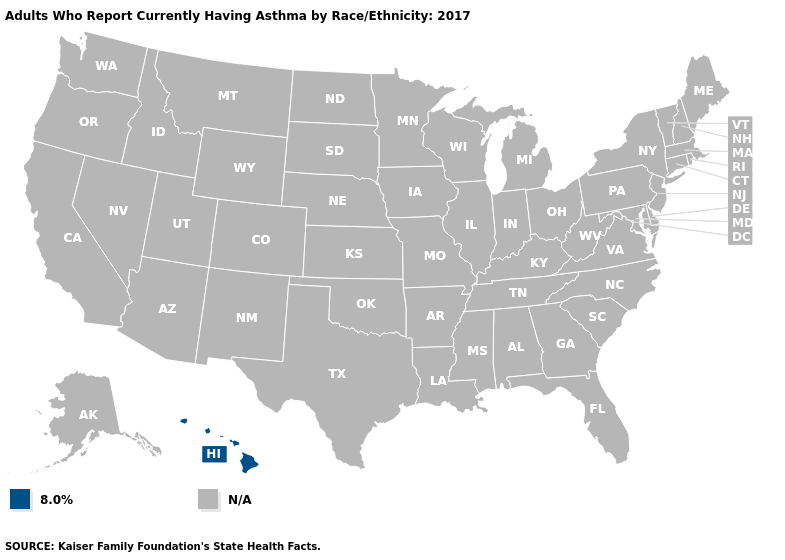How many symbols are there in the legend?
Answer briefly. 2. What is the value of Arkansas?
Write a very short answer. N/A. What is the value of Oregon?
Quick response, please. N/A. How many symbols are there in the legend?
Give a very brief answer. 2. How many symbols are there in the legend?
Short answer required. 2. Name the states that have a value in the range N/A?
Short answer required. Alabama, Alaska, Arizona, Arkansas, California, Colorado, Connecticut, Delaware, Florida, Georgia, Idaho, Illinois, Indiana, Iowa, Kansas, Kentucky, Louisiana, Maine, Maryland, Massachusetts, Michigan, Minnesota, Mississippi, Missouri, Montana, Nebraska, Nevada, New Hampshire, New Jersey, New Mexico, New York, North Carolina, North Dakota, Ohio, Oklahoma, Oregon, Pennsylvania, Rhode Island, South Carolina, South Dakota, Tennessee, Texas, Utah, Vermont, Virginia, Washington, West Virginia, Wisconsin, Wyoming. Name the states that have a value in the range 8.0%?
Be succinct. Hawaii. Name the states that have a value in the range N/A?
Write a very short answer. Alabama, Alaska, Arizona, Arkansas, California, Colorado, Connecticut, Delaware, Florida, Georgia, Idaho, Illinois, Indiana, Iowa, Kansas, Kentucky, Louisiana, Maine, Maryland, Massachusetts, Michigan, Minnesota, Mississippi, Missouri, Montana, Nebraska, Nevada, New Hampshire, New Jersey, New Mexico, New York, North Carolina, North Dakota, Ohio, Oklahoma, Oregon, Pennsylvania, Rhode Island, South Carolina, South Dakota, Tennessee, Texas, Utah, Vermont, Virginia, Washington, West Virginia, Wisconsin, Wyoming. Which states have the lowest value in the USA?
Concise answer only. Hawaii. 